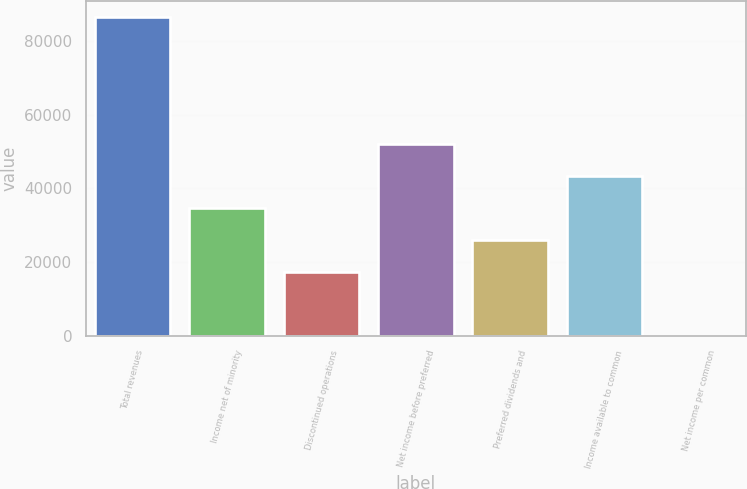Convert chart. <chart><loc_0><loc_0><loc_500><loc_500><bar_chart><fcel>Total revenues<fcel>Income net of minority<fcel>Discontinued operations<fcel>Net income before preferred<fcel>Preferred dividends and<fcel>Income available to common<fcel>Net income per common<nl><fcel>86602<fcel>34641.1<fcel>17320.9<fcel>51961.4<fcel>25981<fcel>43301.3<fcel>0.58<nl></chart> 